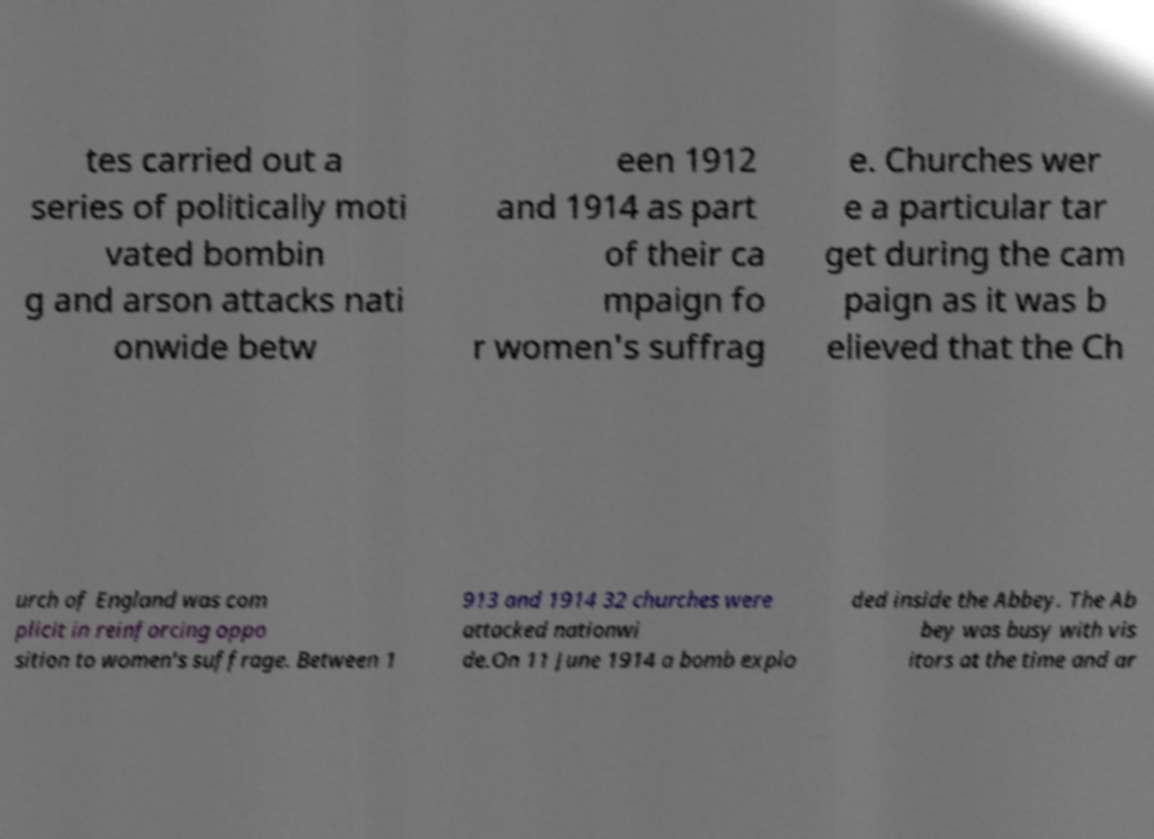Please identify and transcribe the text found in this image. tes carried out a series of politically moti vated bombin g and arson attacks nati onwide betw een 1912 and 1914 as part of their ca mpaign fo r women's suffrag e. Churches wer e a particular tar get during the cam paign as it was b elieved that the Ch urch of England was com plicit in reinforcing oppo sition to women's suffrage. Between 1 913 and 1914 32 churches were attacked nationwi de.On 11 June 1914 a bomb explo ded inside the Abbey. The Ab bey was busy with vis itors at the time and ar 